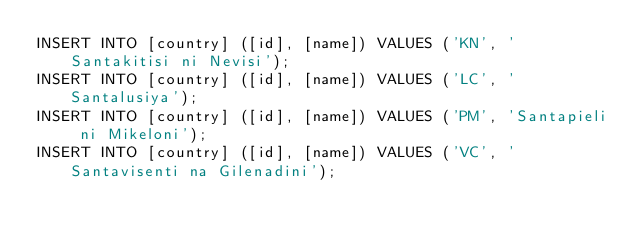Convert code to text. <code><loc_0><loc_0><loc_500><loc_500><_SQL_>INSERT INTO [country] ([id], [name]) VALUES ('KN', 'Santakitisi ni Nevisi');
INSERT INTO [country] ([id], [name]) VALUES ('LC', 'Santalusiya');
INSERT INTO [country] ([id], [name]) VALUES ('PM', 'Santapieli ni Mikeloni');
INSERT INTO [country] ([id], [name]) VALUES ('VC', 'Santavisenti na Gilenadini');</code> 